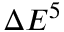Convert formula to latex. <formula><loc_0><loc_0><loc_500><loc_500>\Delta E ^ { 5 }</formula> 